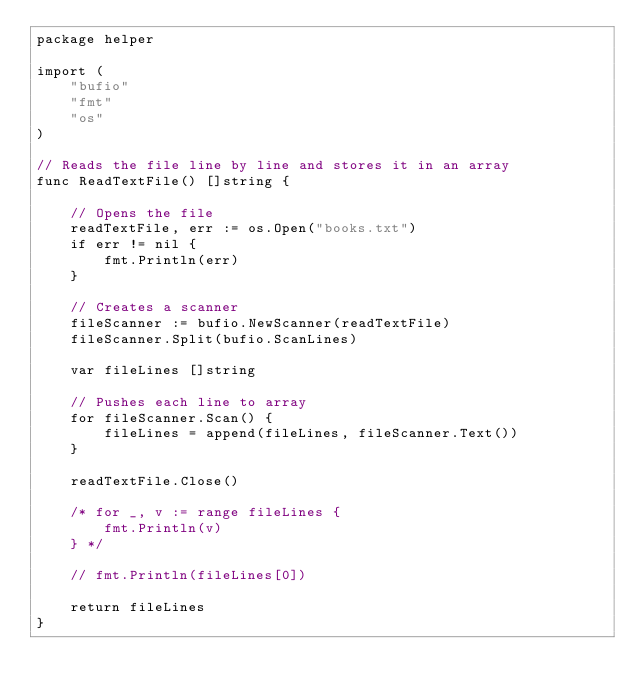<code> <loc_0><loc_0><loc_500><loc_500><_Go_>package helper

import (
	"bufio"
	"fmt"
	"os"
)

// Reads the file line by line and stores it in an array
func ReadTextFile() []string {

	// Opens the file
	readTextFile, err := os.Open("books.txt")
	if err != nil {
		fmt.Println(err)
	}

	// Creates a scanner
	fileScanner := bufio.NewScanner(readTextFile)
	fileScanner.Split(bufio.ScanLines)

	var fileLines []string

	// Pushes each line to array
	for fileScanner.Scan() {
		fileLines = append(fileLines, fileScanner.Text())
	}

	readTextFile.Close()

	/* for _, v := range fileLines {
		fmt.Println(v)
	} */

	// fmt.Println(fileLines[0])

	return fileLines
}
</code> 